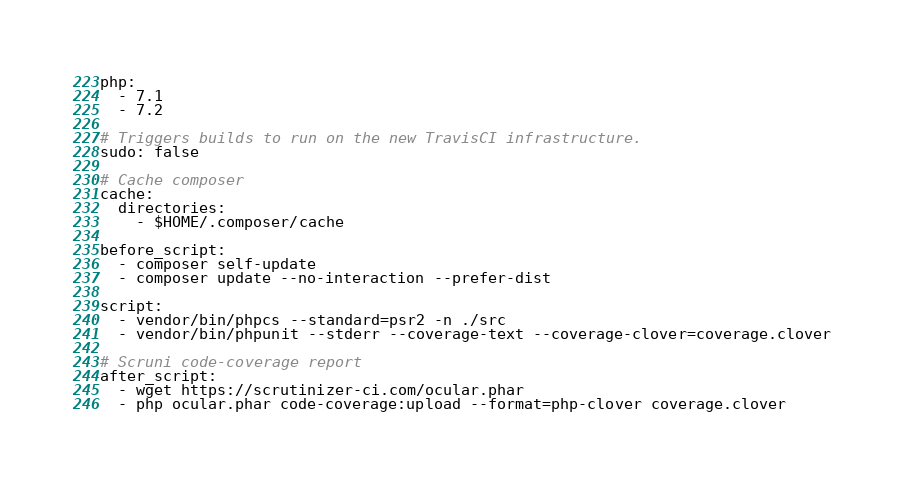Convert code to text. <code><loc_0><loc_0><loc_500><loc_500><_YAML_>
php:
  - 7.1
  - 7.2

# Triggers builds to run on the new TravisCI infrastructure.
sudo: false

# Cache composer
cache:
  directories:
    - $HOME/.composer/cache

before_script:
  - composer self-update
  - composer update --no-interaction --prefer-dist

script:
  - vendor/bin/phpcs --standard=psr2 -n ./src
  - vendor/bin/phpunit --stderr --coverage-text --coverage-clover=coverage.clover

# Scruni code-coverage report
after_script:
  - wget https://scrutinizer-ci.com/ocular.phar
  - php ocular.phar code-coverage:upload --format=php-clover coverage.clover
</code> 